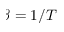<formula> <loc_0><loc_0><loc_500><loc_500>\beta = 1 / T</formula> 